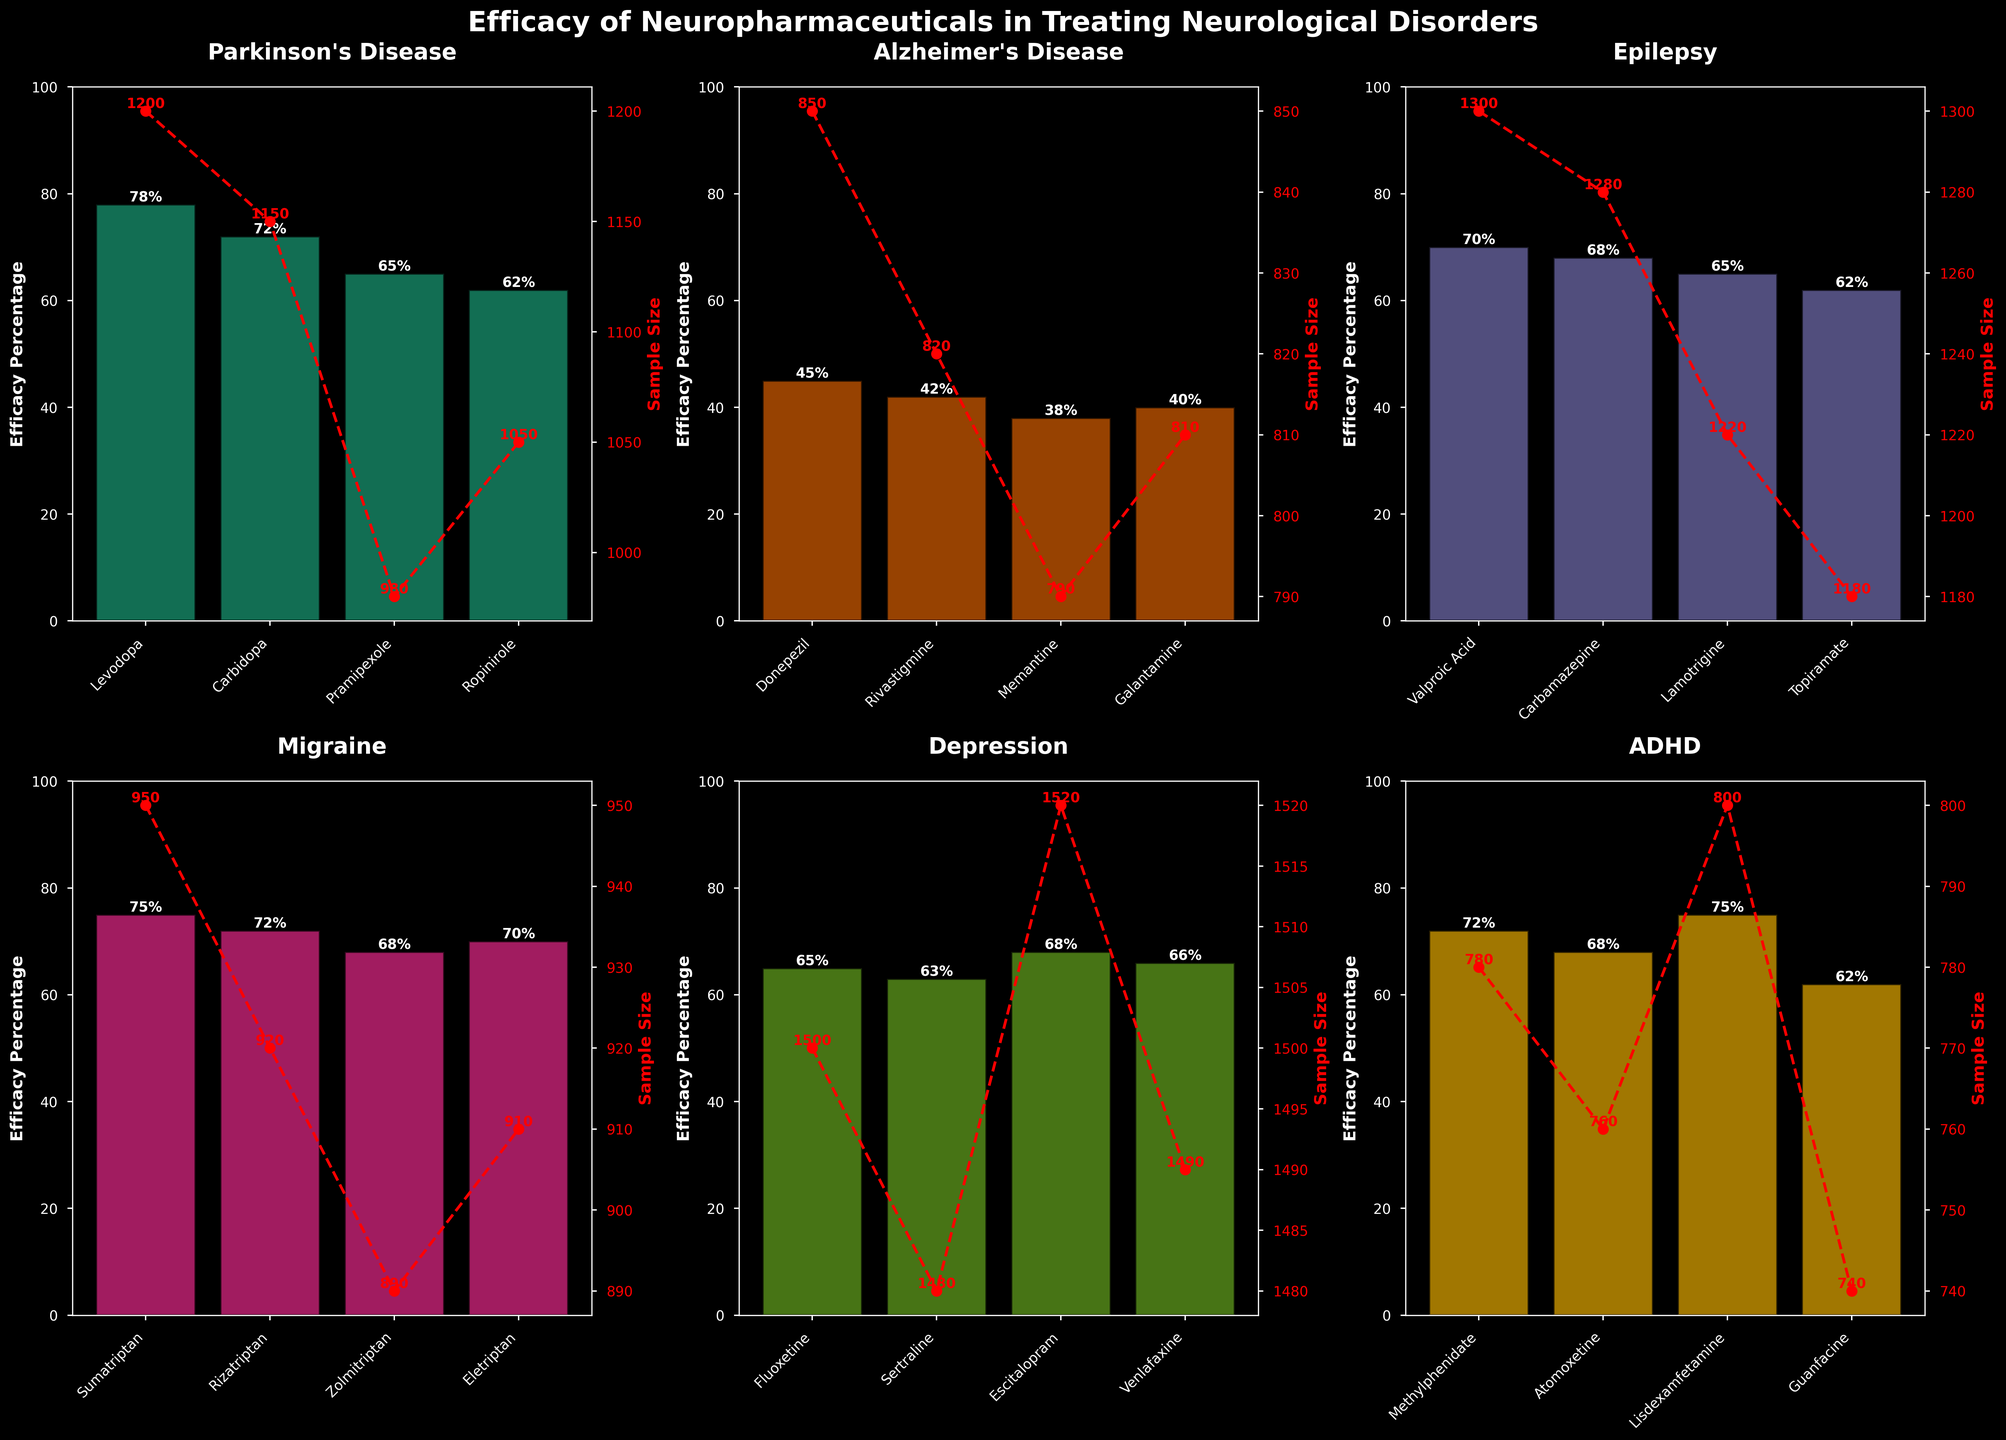Which drug shows the highest efficacy percentage for treating Parkinson's Disease? Look at the subplot for Parkinson's Disease. Compare the heights of the bars. The bar for Levodopa is the tallest.
Answer: Levodopa What is the difference in efficacy percentage between Donepezil and Memantine for Alzheimer's Disease? Locate the Alzheimer's Disease subplot and find the heights of the bars for Donepezil and Memantine. Donepezil has 45% and Memantine has 38%. The difference is 45% - 38%.
Answer: 7% Which drug has the highest sample size for treating Depression? Find the subplot for Depression. Compare the sample size line (red points) for each drug. Escitalopram has the highest sample size.
Answer: Escitalopram What is the average efficacy percentage of all drugs treating Epilepsy? In the Epilepsy subplot, sum the efficacy percentages of Valproic Acid (70%), Carbamazepine (68%), Lamotrigine (65%), and Topiramate (62%). Then divide by 4 (the number of drugs). The calculation is (70 + 68 + 65 + 62) / 4.
Answer: 66.25% How does the efficacy percentage of Fluoxetine compare to Sertraline for treating Depression? Refer to the Depression subplot. Compare the heights of the bars for Fluoxetine and Sertraline. Fluoxetine has 65% and Sertraline has 63%. Fluoxetine is 2% higher.
Answer: Fluoxetine is higher What is the total sample size for all drugs treating ADHD? Summing up the sample sizes for all ADHD drugs: Methylphenidate (780), Atomoxetine (760), Lisdexamfetamine (800), and Guanfacine (740). The total is 780 + 760 + 800 + 740.
Answer: 3080 Which disorder has the drug with the lowest efficacy percentage? Compare the lowest bars across all subplots. The shortest bar is for Memantine (38%) in the Alzheimer's Disease subplot.
Answer: Alzheimer's Disease Is the efficacy percentage of Sumatriptan greater than Rizatriptan for treating Migraines? Check the heights of the bars for Sumatriptan and Rizatriptan in the Migraine subplot. Sumatriptan has 75%, while Rizatriptan has 72%.
Answer: Yes Which drug treating Parkinson's Disease has a sample size close to 1000? In the Parkinson's Disease subplot, the sample sizes are noted in red. Pramipexole, with a sample size of 980, is the closest to 1000.
Answer: Pramipexole Which drug shows both a high efficacy percentage and a high sample size for treating Epilepsy? In the Epilepsy subplot, Valproic Acid has a high efficacy percentage (70%) and a high sample size (1300).
Answer: Valproic Acid 